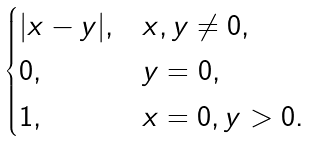Convert formula to latex. <formula><loc_0><loc_0><loc_500><loc_500>\begin{cases} | x - y | , & x , y \not = 0 , \\ 0 , & y = 0 , \\ 1 , & x = 0 , y > 0 . \end{cases}</formula> 